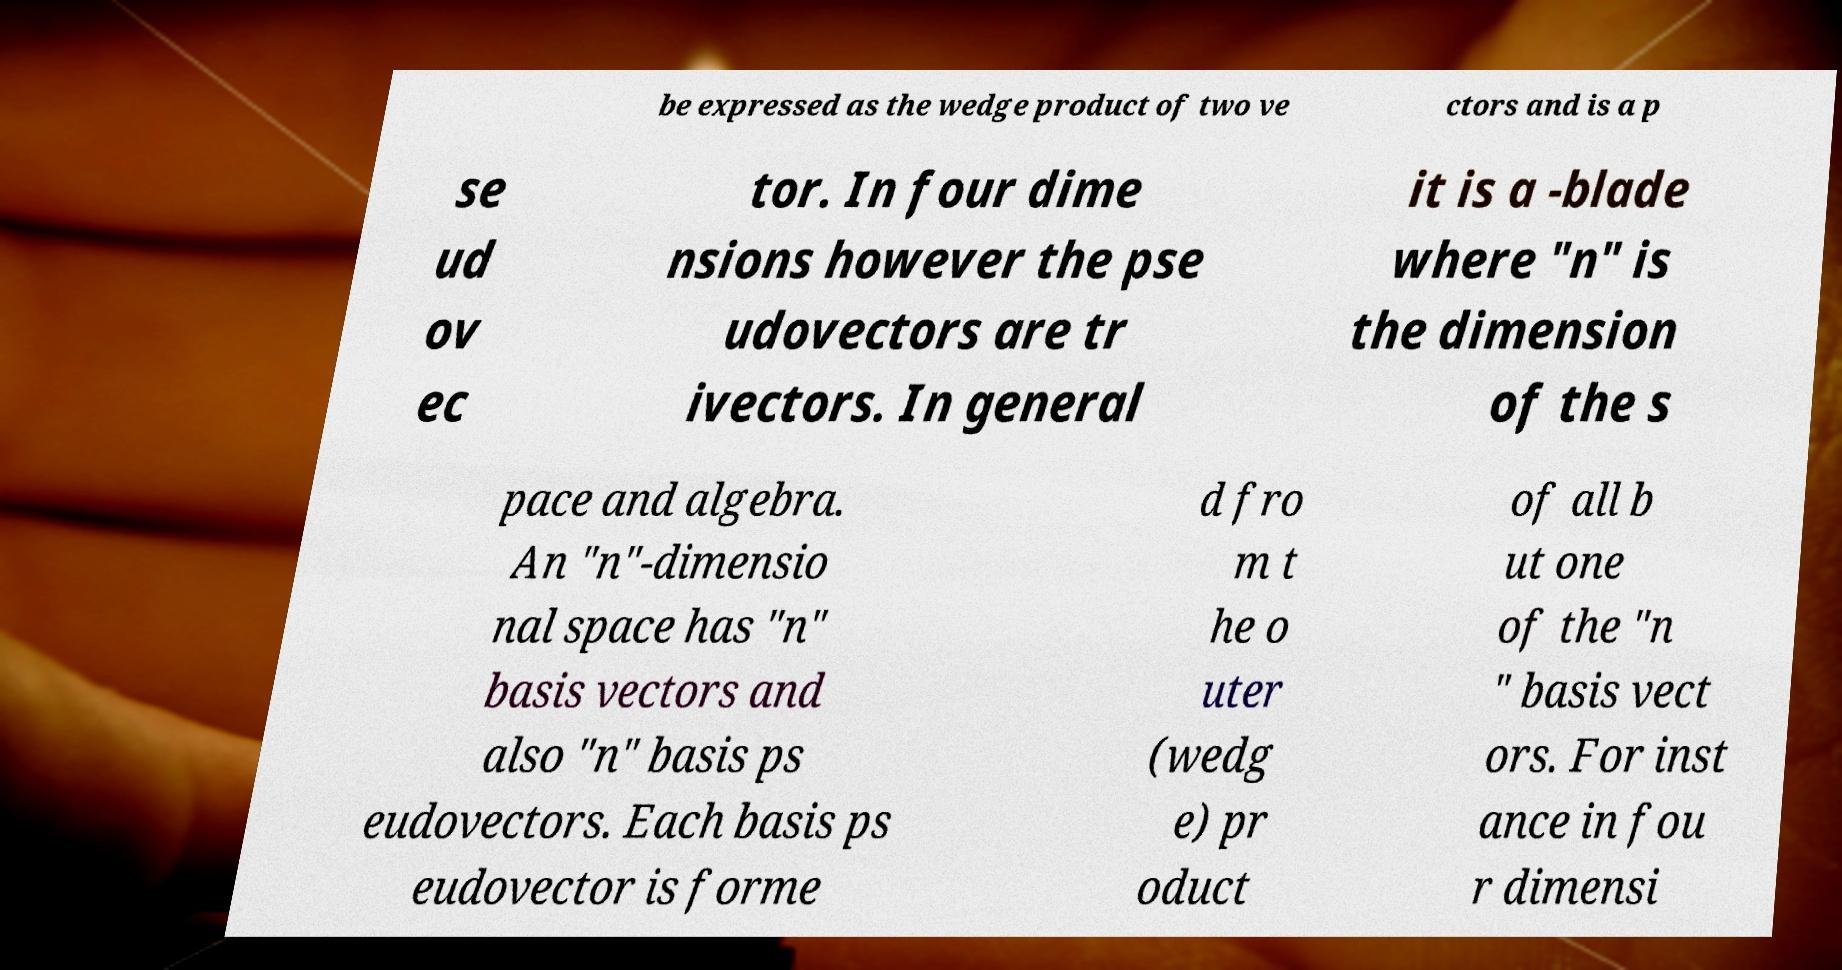Can you accurately transcribe the text from the provided image for me? be expressed as the wedge product of two ve ctors and is a p se ud ov ec tor. In four dime nsions however the pse udovectors are tr ivectors. In general it is a -blade where "n" is the dimension of the s pace and algebra. An "n"-dimensio nal space has "n" basis vectors and also "n" basis ps eudovectors. Each basis ps eudovector is forme d fro m t he o uter (wedg e) pr oduct of all b ut one of the "n " basis vect ors. For inst ance in fou r dimensi 